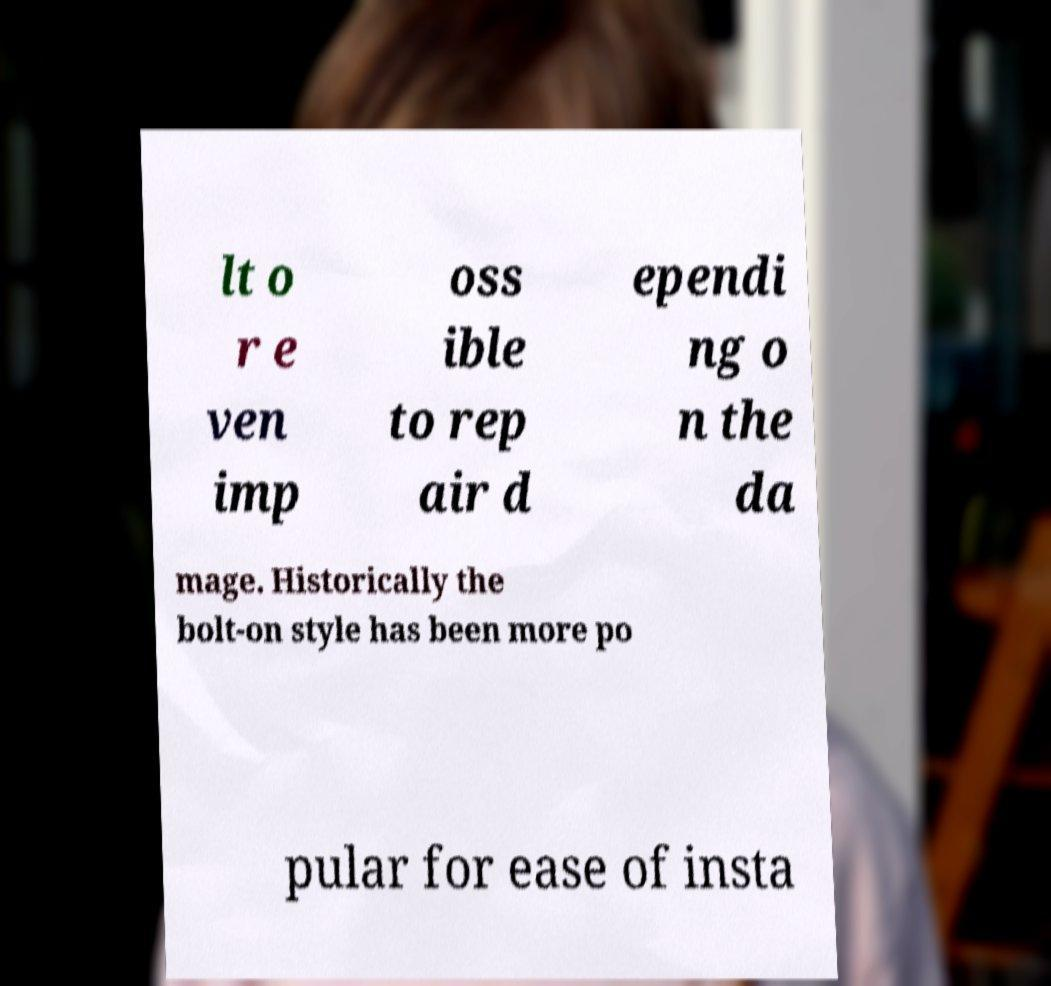Could you assist in decoding the text presented in this image and type it out clearly? lt o r e ven imp oss ible to rep air d ependi ng o n the da mage. Historically the bolt-on style has been more po pular for ease of insta 